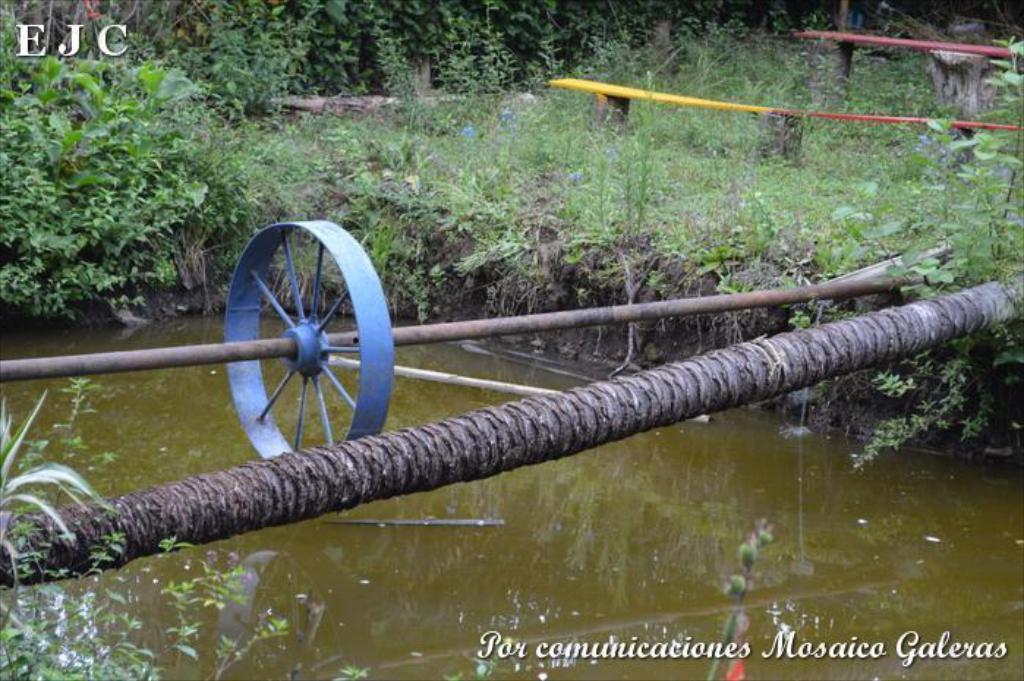Please provide a concise description of this image. In this picture, we see the log which is used to cross the pond. Beside that, we see a blue color wheel. At the bottom, we see water and this water might be in the pond. There are trees and shrubs in the background. We see the wooden benches in red and yellow color. 